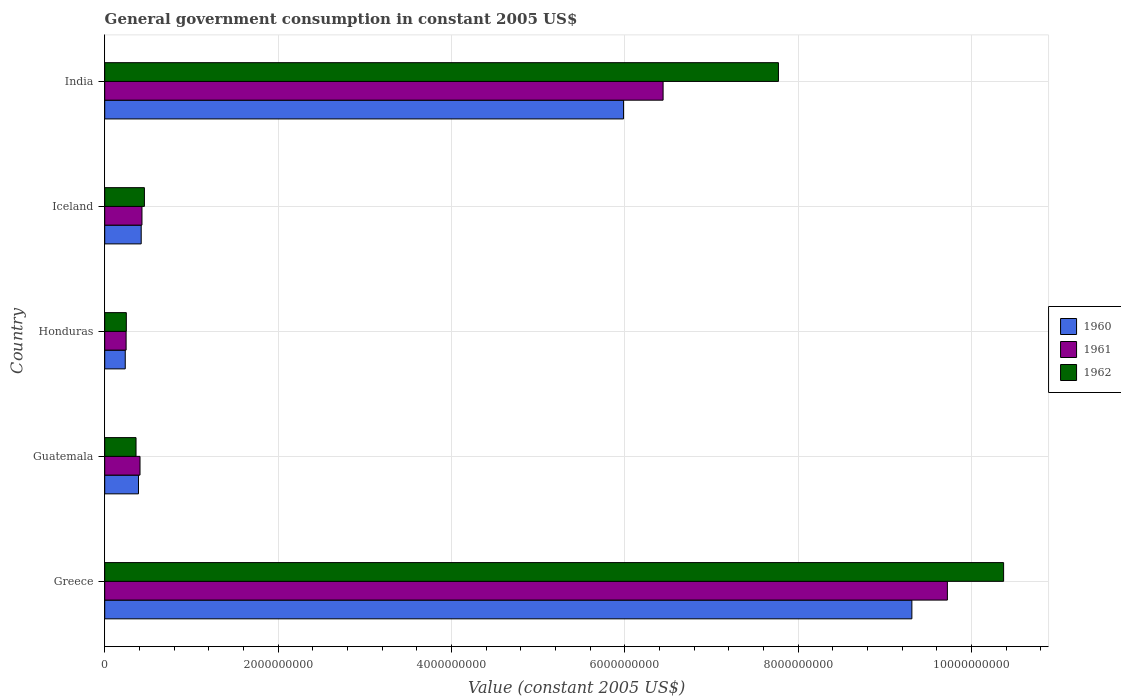How many different coloured bars are there?
Your answer should be very brief. 3. How many groups of bars are there?
Your answer should be very brief. 5. Are the number of bars per tick equal to the number of legend labels?
Provide a succinct answer. Yes. Are the number of bars on each tick of the Y-axis equal?
Give a very brief answer. Yes. How many bars are there on the 5th tick from the top?
Provide a succinct answer. 3. How many bars are there on the 3rd tick from the bottom?
Offer a terse response. 3. What is the label of the 4th group of bars from the top?
Keep it short and to the point. Guatemala. What is the government conusmption in 1962 in Guatemala?
Provide a succinct answer. 3.61e+08. Across all countries, what is the maximum government conusmption in 1961?
Offer a very short reply. 9.72e+09. Across all countries, what is the minimum government conusmption in 1962?
Keep it short and to the point. 2.49e+08. In which country was the government conusmption in 1961 minimum?
Keep it short and to the point. Honduras. What is the total government conusmption in 1961 in the graph?
Give a very brief answer. 1.72e+1. What is the difference between the government conusmption in 1961 in Iceland and that in India?
Keep it short and to the point. -6.01e+09. What is the difference between the government conusmption in 1961 in Honduras and the government conusmption in 1960 in Iceland?
Ensure brevity in your answer.  -1.74e+08. What is the average government conusmption in 1961 per country?
Give a very brief answer. 3.45e+09. What is the difference between the government conusmption in 1961 and government conusmption in 1962 in Iceland?
Your answer should be compact. -2.80e+07. In how many countries, is the government conusmption in 1960 greater than 6400000000 US$?
Your response must be concise. 1. What is the ratio of the government conusmption in 1961 in Guatemala to that in India?
Your response must be concise. 0.06. Is the difference between the government conusmption in 1961 in Greece and Iceland greater than the difference between the government conusmption in 1962 in Greece and Iceland?
Your answer should be compact. No. What is the difference between the highest and the second highest government conusmption in 1960?
Give a very brief answer. 3.33e+09. What is the difference between the highest and the lowest government conusmption in 1961?
Your answer should be very brief. 9.48e+09. In how many countries, is the government conusmption in 1960 greater than the average government conusmption in 1960 taken over all countries?
Your answer should be very brief. 2. How many bars are there?
Your response must be concise. 15. Are all the bars in the graph horizontal?
Give a very brief answer. Yes. Are the values on the major ticks of X-axis written in scientific E-notation?
Make the answer very short. No. How are the legend labels stacked?
Give a very brief answer. Vertical. What is the title of the graph?
Give a very brief answer. General government consumption in constant 2005 US$. What is the label or title of the X-axis?
Provide a short and direct response. Value (constant 2005 US$). What is the Value (constant 2005 US$) of 1960 in Greece?
Provide a short and direct response. 9.31e+09. What is the Value (constant 2005 US$) of 1961 in Greece?
Your answer should be compact. 9.72e+09. What is the Value (constant 2005 US$) in 1962 in Greece?
Offer a very short reply. 1.04e+1. What is the Value (constant 2005 US$) in 1960 in Guatemala?
Your answer should be compact. 3.90e+08. What is the Value (constant 2005 US$) in 1961 in Guatemala?
Ensure brevity in your answer.  4.07e+08. What is the Value (constant 2005 US$) in 1962 in Guatemala?
Your answer should be very brief. 3.61e+08. What is the Value (constant 2005 US$) of 1960 in Honduras?
Make the answer very short. 2.37e+08. What is the Value (constant 2005 US$) in 1961 in Honduras?
Offer a terse response. 2.47e+08. What is the Value (constant 2005 US$) in 1962 in Honduras?
Make the answer very short. 2.49e+08. What is the Value (constant 2005 US$) of 1960 in Iceland?
Offer a very short reply. 4.21e+08. What is the Value (constant 2005 US$) of 1961 in Iceland?
Make the answer very short. 4.30e+08. What is the Value (constant 2005 US$) in 1962 in Iceland?
Provide a short and direct response. 4.58e+08. What is the Value (constant 2005 US$) in 1960 in India?
Make the answer very short. 5.99e+09. What is the Value (constant 2005 US$) in 1961 in India?
Ensure brevity in your answer.  6.44e+09. What is the Value (constant 2005 US$) in 1962 in India?
Make the answer very short. 7.77e+09. Across all countries, what is the maximum Value (constant 2005 US$) of 1960?
Your answer should be compact. 9.31e+09. Across all countries, what is the maximum Value (constant 2005 US$) in 1961?
Your answer should be very brief. 9.72e+09. Across all countries, what is the maximum Value (constant 2005 US$) of 1962?
Provide a short and direct response. 1.04e+1. Across all countries, what is the minimum Value (constant 2005 US$) in 1960?
Provide a succinct answer. 2.37e+08. Across all countries, what is the minimum Value (constant 2005 US$) of 1961?
Give a very brief answer. 2.47e+08. Across all countries, what is the minimum Value (constant 2005 US$) in 1962?
Your answer should be compact. 2.49e+08. What is the total Value (constant 2005 US$) in 1960 in the graph?
Give a very brief answer. 1.63e+1. What is the total Value (constant 2005 US$) in 1961 in the graph?
Give a very brief answer. 1.72e+1. What is the total Value (constant 2005 US$) of 1962 in the graph?
Offer a very short reply. 1.92e+1. What is the difference between the Value (constant 2005 US$) in 1960 in Greece and that in Guatemala?
Offer a terse response. 8.92e+09. What is the difference between the Value (constant 2005 US$) of 1961 in Greece and that in Guatemala?
Make the answer very short. 9.32e+09. What is the difference between the Value (constant 2005 US$) of 1962 in Greece and that in Guatemala?
Give a very brief answer. 1.00e+1. What is the difference between the Value (constant 2005 US$) of 1960 in Greece and that in Honduras?
Your answer should be very brief. 9.08e+09. What is the difference between the Value (constant 2005 US$) of 1961 in Greece and that in Honduras?
Offer a very short reply. 9.48e+09. What is the difference between the Value (constant 2005 US$) in 1962 in Greece and that in Honduras?
Offer a very short reply. 1.01e+1. What is the difference between the Value (constant 2005 US$) of 1960 in Greece and that in Iceland?
Give a very brief answer. 8.89e+09. What is the difference between the Value (constant 2005 US$) in 1961 in Greece and that in Iceland?
Offer a terse response. 9.29e+09. What is the difference between the Value (constant 2005 US$) in 1962 in Greece and that in Iceland?
Your answer should be compact. 9.91e+09. What is the difference between the Value (constant 2005 US$) in 1960 in Greece and that in India?
Provide a short and direct response. 3.33e+09. What is the difference between the Value (constant 2005 US$) of 1961 in Greece and that in India?
Give a very brief answer. 3.28e+09. What is the difference between the Value (constant 2005 US$) of 1962 in Greece and that in India?
Your answer should be compact. 2.60e+09. What is the difference between the Value (constant 2005 US$) in 1960 in Guatemala and that in Honduras?
Ensure brevity in your answer.  1.53e+08. What is the difference between the Value (constant 2005 US$) in 1961 in Guatemala and that in Honduras?
Make the answer very short. 1.60e+08. What is the difference between the Value (constant 2005 US$) in 1962 in Guatemala and that in Honduras?
Offer a terse response. 1.12e+08. What is the difference between the Value (constant 2005 US$) in 1960 in Guatemala and that in Iceland?
Make the answer very short. -3.13e+07. What is the difference between the Value (constant 2005 US$) in 1961 in Guatemala and that in Iceland?
Offer a very short reply. -2.26e+07. What is the difference between the Value (constant 2005 US$) in 1962 in Guatemala and that in Iceland?
Your answer should be compact. -9.66e+07. What is the difference between the Value (constant 2005 US$) in 1960 in Guatemala and that in India?
Ensure brevity in your answer.  -5.60e+09. What is the difference between the Value (constant 2005 US$) of 1961 in Guatemala and that in India?
Your response must be concise. -6.04e+09. What is the difference between the Value (constant 2005 US$) of 1962 in Guatemala and that in India?
Your response must be concise. -7.41e+09. What is the difference between the Value (constant 2005 US$) of 1960 in Honduras and that in Iceland?
Make the answer very short. -1.84e+08. What is the difference between the Value (constant 2005 US$) of 1961 in Honduras and that in Iceland?
Your response must be concise. -1.83e+08. What is the difference between the Value (constant 2005 US$) of 1962 in Honduras and that in Iceland?
Offer a very short reply. -2.09e+08. What is the difference between the Value (constant 2005 US$) in 1960 in Honduras and that in India?
Make the answer very short. -5.75e+09. What is the difference between the Value (constant 2005 US$) of 1961 in Honduras and that in India?
Your response must be concise. -6.20e+09. What is the difference between the Value (constant 2005 US$) in 1962 in Honduras and that in India?
Your response must be concise. -7.52e+09. What is the difference between the Value (constant 2005 US$) of 1960 in Iceland and that in India?
Offer a very short reply. -5.57e+09. What is the difference between the Value (constant 2005 US$) in 1961 in Iceland and that in India?
Provide a short and direct response. -6.01e+09. What is the difference between the Value (constant 2005 US$) in 1962 in Iceland and that in India?
Your response must be concise. -7.32e+09. What is the difference between the Value (constant 2005 US$) in 1960 in Greece and the Value (constant 2005 US$) in 1961 in Guatemala?
Your answer should be very brief. 8.91e+09. What is the difference between the Value (constant 2005 US$) in 1960 in Greece and the Value (constant 2005 US$) in 1962 in Guatemala?
Your response must be concise. 8.95e+09. What is the difference between the Value (constant 2005 US$) in 1961 in Greece and the Value (constant 2005 US$) in 1962 in Guatemala?
Make the answer very short. 9.36e+09. What is the difference between the Value (constant 2005 US$) in 1960 in Greece and the Value (constant 2005 US$) in 1961 in Honduras?
Keep it short and to the point. 9.07e+09. What is the difference between the Value (constant 2005 US$) in 1960 in Greece and the Value (constant 2005 US$) in 1962 in Honduras?
Your response must be concise. 9.06e+09. What is the difference between the Value (constant 2005 US$) in 1961 in Greece and the Value (constant 2005 US$) in 1962 in Honduras?
Provide a short and direct response. 9.47e+09. What is the difference between the Value (constant 2005 US$) of 1960 in Greece and the Value (constant 2005 US$) of 1961 in Iceland?
Ensure brevity in your answer.  8.88e+09. What is the difference between the Value (constant 2005 US$) in 1960 in Greece and the Value (constant 2005 US$) in 1962 in Iceland?
Give a very brief answer. 8.86e+09. What is the difference between the Value (constant 2005 US$) in 1961 in Greece and the Value (constant 2005 US$) in 1962 in Iceland?
Your response must be concise. 9.26e+09. What is the difference between the Value (constant 2005 US$) in 1960 in Greece and the Value (constant 2005 US$) in 1961 in India?
Offer a very short reply. 2.87e+09. What is the difference between the Value (constant 2005 US$) of 1960 in Greece and the Value (constant 2005 US$) of 1962 in India?
Your answer should be compact. 1.54e+09. What is the difference between the Value (constant 2005 US$) of 1961 in Greece and the Value (constant 2005 US$) of 1962 in India?
Give a very brief answer. 1.95e+09. What is the difference between the Value (constant 2005 US$) in 1960 in Guatemala and the Value (constant 2005 US$) in 1961 in Honduras?
Provide a succinct answer. 1.43e+08. What is the difference between the Value (constant 2005 US$) in 1960 in Guatemala and the Value (constant 2005 US$) in 1962 in Honduras?
Your response must be concise. 1.40e+08. What is the difference between the Value (constant 2005 US$) in 1961 in Guatemala and the Value (constant 2005 US$) in 1962 in Honduras?
Provide a short and direct response. 1.58e+08. What is the difference between the Value (constant 2005 US$) in 1960 in Guatemala and the Value (constant 2005 US$) in 1961 in Iceland?
Ensure brevity in your answer.  -4.02e+07. What is the difference between the Value (constant 2005 US$) of 1960 in Guatemala and the Value (constant 2005 US$) of 1962 in Iceland?
Your response must be concise. -6.82e+07. What is the difference between the Value (constant 2005 US$) in 1961 in Guatemala and the Value (constant 2005 US$) in 1962 in Iceland?
Your answer should be compact. -5.06e+07. What is the difference between the Value (constant 2005 US$) in 1960 in Guatemala and the Value (constant 2005 US$) in 1961 in India?
Offer a very short reply. -6.05e+09. What is the difference between the Value (constant 2005 US$) in 1960 in Guatemala and the Value (constant 2005 US$) in 1962 in India?
Offer a terse response. -7.38e+09. What is the difference between the Value (constant 2005 US$) of 1961 in Guatemala and the Value (constant 2005 US$) of 1962 in India?
Your answer should be very brief. -7.37e+09. What is the difference between the Value (constant 2005 US$) in 1960 in Honduras and the Value (constant 2005 US$) in 1961 in Iceland?
Give a very brief answer. -1.93e+08. What is the difference between the Value (constant 2005 US$) in 1960 in Honduras and the Value (constant 2005 US$) in 1962 in Iceland?
Your response must be concise. -2.21e+08. What is the difference between the Value (constant 2005 US$) in 1961 in Honduras and the Value (constant 2005 US$) in 1962 in Iceland?
Give a very brief answer. -2.11e+08. What is the difference between the Value (constant 2005 US$) in 1960 in Honduras and the Value (constant 2005 US$) in 1961 in India?
Provide a short and direct response. -6.21e+09. What is the difference between the Value (constant 2005 US$) of 1960 in Honduras and the Value (constant 2005 US$) of 1962 in India?
Your answer should be compact. -7.54e+09. What is the difference between the Value (constant 2005 US$) in 1961 in Honduras and the Value (constant 2005 US$) in 1962 in India?
Give a very brief answer. -7.53e+09. What is the difference between the Value (constant 2005 US$) of 1960 in Iceland and the Value (constant 2005 US$) of 1961 in India?
Your answer should be very brief. -6.02e+09. What is the difference between the Value (constant 2005 US$) of 1960 in Iceland and the Value (constant 2005 US$) of 1962 in India?
Offer a terse response. -7.35e+09. What is the difference between the Value (constant 2005 US$) of 1961 in Iceland and the Value (constant 2005 US$) of 1962 in India?
Offer a terse response. -7.34e+09. What is the average Value (constant 2005 US$) in 1960 per country?
Keep it short and to the point. 3.27e+09. What is the average Value (constant 2005 US$) of 1961 per country?
Offer a very short reply. 3.45e+09. What is the average Value (constant 2005 US$) in 1962 per country?
Ensure brevity in your answer.  3.84e+09. What is the difference between the Value (constant 2005 US$) of 1960 and Value (constant 2005 US$) of 1961 in Greece?
Your answer should be compact. -4.10e+08. What is the difference between the Value (constant 2005 US$) of 1960 and Value (constant 2005 US$) of 1962 in Greece?
Your answer should be very brief. -1.06e+09. What is the difference between the Value (constant 2005 US$) of 1961 and Value (constant 2005 US$) of 1962 in Greece?
Offer a terse response. -6.49e+08. What is the difference between the Value (constant 2005 US$) in 1960 and Value (constant 2005 US$) in 1961 in Guatemala?
Give a very brief answer. -1.76e+07. What is the difference between the Value (constant 2005 US$) of 1960 and Value (constant 2005 US$) of 1962 in Guatemala?
Make the answer very short. 2.84e+07. What is the difference between the Value (constant 2005 US$) in 1961 and Value (constant 2005 US$) in 1962 in Guatemala?
Your answer should be very brief. 4.60e+07. What is the difference between the Value (constant 2005 US$) of 1960 and Value (constant 2005 US$) of 1961 in Honduras?
Your answer should be very brief. -9.99e+06. What is the difference between the Value (constant 2005 US$) in 1960 and Value (constant 2005 US$) in 1962 in Honduras?
Make the answer very short. -1.24e+07. What is the difference between the Value (constant 2005 US$) of 1961 and Value (constant 2005 US$) of 1962 in Honduras?
Ensure brevity in your answer.  -2.42e+06. What is the difference between the Value (constant 2005 US$) in 1960 and Value (constant 2005 US$) in 1961 in Iceland?
Give a very brief answer. -8.87e+06. What is the difference between the Value (constant 2005 US$) in 1960 and Value (constant 2005 US$) in 1962 in Iceland?
Give a very brief answer. -3.69e+07. What is the difference between the Value (constant 2005 US$) in 1961 and Value (constant 2005 US$) in 1962 in Iceland?
Provide a short and direct response. -2.80e+07. What is the difference between the Value (constant 2005 US$) of 1960 and Value (constant 2005 US$) of 1961 in India?
Your response must be concise. -4.56e+08. What is the difference between the Value (constant 2005 US$) of 1960 and Value (constant 2005 US$) of 1962 in India?
Your answer should be compact. -1.79e+09. What is the difference between the Value (constant 2005 US$) of 1961 and Value (constant 2005 US$) of 1962 in India?
Ensure brevity in your answer.  -1.33e+09. What is the ratio of the Value (constant 2005 US$) in 1960 in Greece to that in Guatemala?
Provide a succinct answer. 23.9. What is the ratio of the Value (constant 2005 US$) of 1961 in Greece to that in Guatemala?
Keep it short and to the point. 23.87. What is the ratio of the Value (constant 2005 US$) of 1962 in Greece to that in Guatemala?
Your answer should be compact. 28.71. What is the ratio of the Value (constant 2005 US$) in 1960 in Greece to that in Honduras?
Ensure brevity in your answer.  39.32. What is the ratio of the Value (constant 2005 US$) in 1961 in Greece to that in Honduras?
Your answer should be very brief. 39.39. What is the ratio of the Value (constant 2005 US$) of 1962 in Greece to that in Honduras?
Provide a succinct answer. 41.61. What is the ratio of the Value (constant 2005 US$) of 1960 in Greece to that in Iceland?
Give a very brief answer. 22.12. What is the ratio of the Value (constant 2005 US$) in 1961 in Greece to that in Iceland?
Provide a short and direct response. 22.62. What is the ratio of the Value (constant 2005 US$) in 1962 in Greece to that in Iceland?
Make the answer very short. 22.65. What is the ratio of the Value (constant 2005 US$) in 1960 in Greece to that in India?
Give a very brief answer. 1.56. What is the ratio of the Value (constant 2005 US$) of 1961 in Greece to that in India?
Offer a terse response. 1.51. What is the ratio of the Value (constant 2005 US$) of 1962 in Greece to that in India?
Keep it short and to the point. 1.33. What is the ratio of the Value (constant 2005 US$) in 1960 in Guatemala to that in Honduras?
Provide a succinct answer. 1.65. What is the ratio of the Value (constant 2005 US$) in 1961 in Guatemala to that in Honduras?
Provide a short and direct response. 1.65. What is the ratio of the Value (constant 2005 US$) of 1962 in Guatemala to that in Honduras?
Make the answer very short. 1.45. What is the ratio of the Value (constant 2005 US$) in 1960 in Guatemala to that in Iceland?
Ensure brevity in your answer.  0.93. What is the ratio of the Value (constant 2005 US$) of 1961 in Guatemala to that in Iceland?
Provide a succinct answer. 0.95. What is the ratio of the Value (constant 2005 US$) in 1962 in Guatemala to that in Iceland?
Give a very brief answer. 0.79. What is the ratio of the Value (constant 2005 US$) of 1960 in Guatemala to that in India?
Your response must be concise. 0.07. What is the ratio of the Value (constant 2005 US$) of 1961 in Guatemala to that in India?
Your response must be concise. 0.06. What is the ratio of the Value (constant 2005 US$) in 1962 in Guatemala to that in India?
Offer a terse response. 0.05. What is the ratio of the Value (constant 2005 US$) in 1960 in Honduras to that in Iceland?
Your answer should be compact. 0.56. What is the ratio of the Value (constant 2005 US$) of 1961 in Honduras to that in Iceland?
Give a very brief answer. 0.57. What is the ratio of the Value (constant 2005 US$) in 1962 in Honduras to that in Iceland?
Your response must be concise. 0.54. What is the ratio of the Value (constant 2005 US$) in 1960 in Honduras to that in India?
Ensure brevity in your answer.  0.04. What is the ratio of the Value (constant 2005 US$) in 1961 in Honduras to that in India?
Your response must be concise. 0.04. What is the ratio of the Value (constant 2005 US$) in 1962 in Honduras to that in India?
Provide a succinct answer. 0.03. What is the ratio of the Value (constant 2005 US$) in 1960 in Iceland to that in India?
Give a very brief answer. 0.07. What is the ratio of the Value (constant 2005 US$) of 1961 in Iceland to that in India?
Your response must be concise. 0.07. What is the ratio of the Value (constant 2005 US$) of 1962 in Iceland to that in India?
Your response must be concise. 0.06. What is the difference between the highest and the second highest Value (constant 2005 US$) of 1960?
Keep it short and to the point. 3.33e+09. What is the difference between the highest and the second highest Value (constant 2005 US$) of 1961?
Give a very brief answer. 3.28e+09. What is the difference between the highest and the second highest Value (constant 2005 US$) in 1962?
Your response must be concise. 2.60e+09. What is the difference between the highest and the lowest Value (constant 2005 US$) in 1960?
Your answer should be very brief. 9.08e+09. What is the difference between the highest and the lowest Value (constant 2005 US$) of 1961?
Make the answer very short. 9.48e+09. What is the difference between the highest and the lowest Value (constant 2005 US$) of 1962?
Make the answer very short. 1.01e+1. 